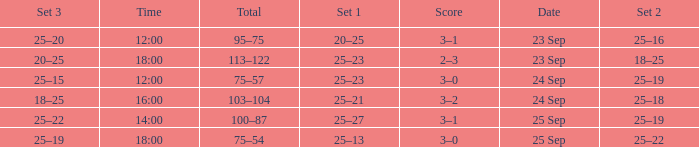What was the score when the time was 14:00? 3–1. 